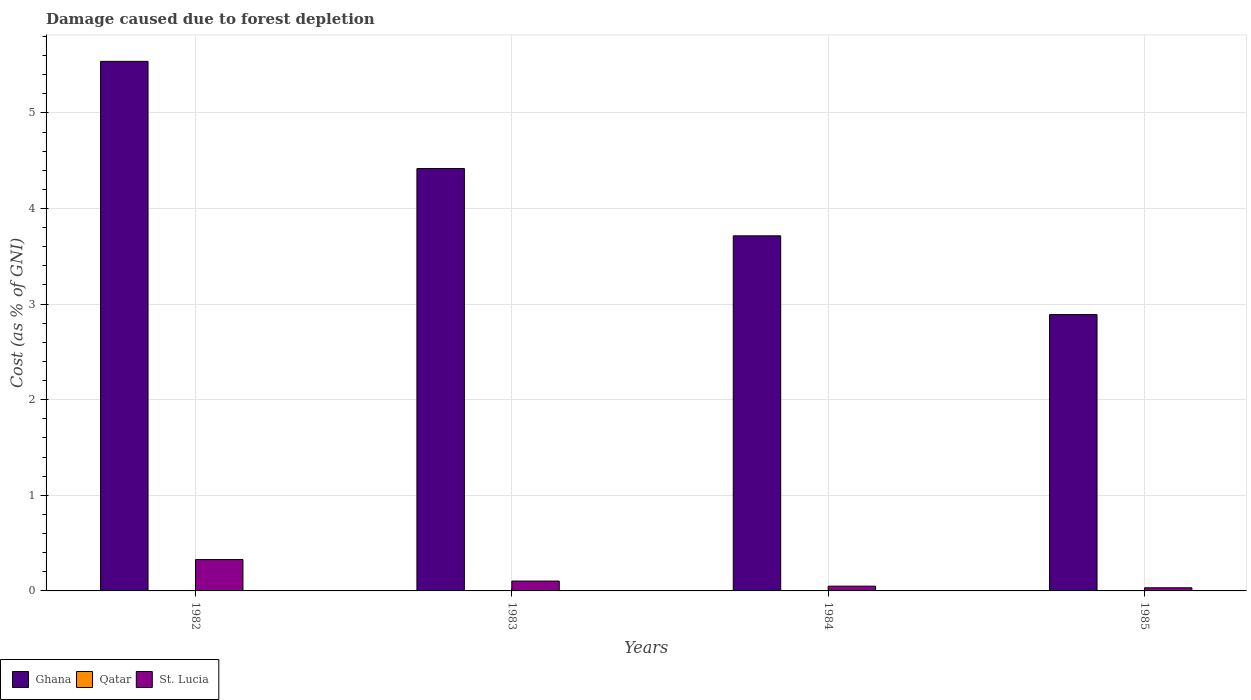How many different coloured bars are there?
Ensure brevity in your answer.  3. Are the number of bars on each tick of the X-axis equal?
Your answer should be compact. Yes. How many bars are there on the 4th tick from the left?
Give a very brief answer. 3. How many bars are there on the 3rd tick from the right?
Give a very brief answer. 3. What is the label of the 1st group of bars from the left?
Your answer should be very brief. 1982. In how many cases, is the number of bars for a given year not equal to the number of legend labels?
Make the answer very short. 0. What is the cost of damage caused due to forest depletion in Qatar in 1985?
Ensure brevity in your answer.  0. Across all years, what is the maximum cost of damage caused due to forest depletion in St. Lucia?
Make the answer very short. 0.33. Across all years, what is the minimum cost of damage caused due to forest depletion in Qatar?
Provide a succinct answer. 0. What is the total cost of damage caused due to forest depletion in St. Lucia in the graph?
Provide a succinct answer. 0.51. What is the difference between the cost of damage caused due to forest depletion in St. Lucia in 1983 and that in 1985?
Your answer should be compact. 0.07. What is the difference between the cost of damage caused due to forest depletion in Qatar in 1983 and the cost of damage caused due to forest depletion in St. Lucia in 1985?
Provide a short and direct response. -0.03. What is the average cost of damage caused due to forest depletion in Qatar per year?
Make the answer very short. 0. In the year 1984, what is the difference between the cost of damage caused due to forest depletion in Ghana and cost of damage caused due to forest depletion in St. Lucia?
Keep it short and to the point. 3.66. In how many years, is the cost of damage caused due to forest depletion in Qatar greater than 5.4 %?
Provide a succinct answer. 0. What is the ratio of the cost of damage caused due to forest depletion in Qatar in 1982 to that in 1983?
Your answer should be compact. 0.86. Is the cost of damage caused due to forest depletion in Ghana in 1982 less than that in 1984?
Your answer should be compact. No. Is the difference between the cost of damage caused due to forest depletion in Ghana in 1983 and 1984 greater than the difference between the cost of damage caused due to forest depletion in St. Lucia in 1983 and 1984?
Your answer should be compact. Yes. What is the difference between the highest and the second highest cost of damage caused due to forest depletion in Ghana?
Provide a succinct answer. 1.12. What is the difference between the highest and the lowest cost of damage caused due to forest depletion in Qatar?
Your answer should be compact. 0. Is the sum of the cost of damage caused due to forest depletion in St. Lucia in 1984 and 1985 greater than the maximum cost of damage caused due to forest depletion in Qatar across all years?
Offer a very short reply. Yes. How many bars are there?
Keep it short and to the point. 12. Are all the bars in the graph horizontal?
Offer a terse response. No. What is the difference between two consecutive major ticks on the Y-axis?
Provide a short and direct response. 1. Are the values on the major ticks of Y-axis written in scientific E-notation?
Provide a succinct answer. No. Does the graph contain any zero values?
Offer a terse response. No. How are the legend labels stacked?
Your response must be concise. Horizontal. What is the title of the graph?
Provide a succinct answer. Damage caused due to forest depletion. Does "San Marino" appear as one of the legend labels in the graph?
Your response must be concise. No. What is the label or title of the X-axis?
Your answer should be very brief. Years. What is the label or title of the Y-axis?
Provide a short and direct response. Cost (as % of GNI). What is the Cost (as % of GNI) in Ghana in 1982?
Make the answer very short. 5.54. What is the Cost (as % of GNI) of Qatar in 1982?
Your response must be concise. 0. What is the Cost (as % of GNI) in St. Lucia in 1982?
Keep it short and to the point. 0.33. What is the Cost (as % of GNI) of Ghana in 1983?
Keep it short and to the point. 4.42. What is the Cost (as % of GNI) in Qatar in 1983?
Your answer should be compact. 0. What is the Cost (as % of GNI) of St. Lucia in 1983?
Your answer should be compact. 0.1. What is the Cost (as % of GNI) of Ghana in 1984?
Keep it short and to the point. 3.71. What is the Cost (as % of GNI) of Qatar in 1984?
Your answer should be very brief. 0. What is the Cost (as % of GNI) of St. Lucia in 1984?
Your answer should be very brief. 0.05. What is the Cost (as % of GNI) of Ghana in 1985?
Provide a short and direct response. 2.89. What is the Cost (as % of GNI) of Qatar in 1985?
Give a very brief answer. 0. What is the Cost (as % of GNI) in St. Lucia in 1985?
Ensure brevity in your answer.  0.03. Across all years, what is the maximum Cost (as % of GNI) in Ghana?
Provide a short and direct response. 5.54. Across all years, what is the maximum Cost (as % of GNI) of Qatar?
Provide a succinct answer. 0. Across all years, what is the maximum Cost (as % of GNI) of St. Lucia?
Offer a terse response. 0.33. Across all years, what is the minimum Cost (as % of GNI) of Ghana?
Give a very brief answer. 2.89. Across all years, what is the minimum Cost (as % of GNI) in Qatar?
Provide a succinct answer. 0. Across all years, what is the minimum Cost (as % of GNI) in St. Lucia?
Keep it short and to the point. 0.03. What is the total Cost (as % of GNI) in Ghana in the graph?
Provide a short and direct response. 16.56. What is the total Cost (as % of GNI) in Qatar in the graph?
Your answer should be very brief. 0. What is the total Cost (as % of GNI) of St. Lucia in the graph?
Provide a succinct answer. 0.51. What is the difference between the Cost (as % of GNI) in Ghana in 1982 and that in 1983?
Your response must be concise. 1.12. What is the difference between the Cost (as % of GNI) in Qatar in 1982 and that in 1983?
Your response must be concise. -0. What is the difference between the Cost (as % of GNI) in St. Lucia in 1982 and that in 1983?
Offer a very short reply. 0.22. What is the difference between the Cost (as % of GNI) of Ghana in 1982 and that in 1984?
Your answer should be compact. 1.83. What is the difference between the Cost (as % of GNI) in Qatar in 1982 and that in 1984?
Give a very brief answer. -0. What is the difference between the Cost (as % of GNI) of St. Lucia in 1982 and that in 1984?
Offer a very short reply. 0.28. What is the difference between the Cost (as % of GNI) of Ghana in 1982 and that in 1985?
Give a very brief answer. 2.65. What is the difference between the Cost (as % of GNI) in St. Lucia in 1982 and that in 1985?
Offer a very short reply. 0.29. What is the difference between the Cost (as % of GNI) of Ghana in 1983 and that in 1984?
Make the answer very short. 0.7. What is the difference between the Cost (as % of GNI) of Qatar in 1983 and that in 1984?
Your answer should be compact. -0. What is the difference between the Cost (as % of GNI) of St. Lucia in 1983 and that in 1984?
Offer a very short reply. 0.05. What is the difference between the Cost (as % of GNI) in Ghana in 1983 and that in 1985?
Offer a terse response. 1.53. What is the difference between the Cost (as % of GNI) of St. Lucia in 1983 and that in 1985?
Keep it short and to the point. 0.07. What is the difference between the Cost (as % of GNI) of Ghana in 1984 and that in 1985?
Provide a short and direct response. 0.82. What is the difference between the Cost (as % of GNI) of Qatar in 1984 and that in 1985?
Offer a very short reply. 0. What is the difference between the Cost (as % of GNI) in St. Lucia in 1984 and that in 1985?
Provide a succinct answer. 0.02. What is the difference between the Cost (as % of GNI) in Ghana in 1982 and the Cost (as % of GNI) in Qatar in 1983?
Give a very brief answer. 5.54. What is the difference between the Cost (as % of GNI) of Ghana in 1982 and the Cost (as % of GNI) of St. Lucia in 1983?
Provide a short and direct response. 5.44. What is the difference between the Cost (as % of GNI) of Qatar in 1982 and the Cost (as % of GNI) of St. Lucia in 1983?
Offer a terse response. -0.1. What is the difference between the Cost (as % of GNI) of Ghana in 1982 and the Cost (as % of GNI) of Qatar in 1984?
Provide a succinct answer. 5.54. What is the difference between the Cost (as % of GNI) of Ghana in 1982 and the Cost (as % of GNI) of St. Lucia in 1984?
Make the answer very short. 5.49. What is the difference between the Cost (as % of GNI) in Qatar in 1982 and the Cost (as % of GNI) in St. Lucia in 1984?
Give a very brief answer. -0.05. What is the difference between the Cost (as % of GNI) in Ghana in 1982 and the Cost (as % of GNI) in Qatar in 1985?
Your response must be concise. 5.54. What is the difference between the Cost (as % of GNI) of Ghana in 1982 and the Cost (as % of GNI) of St. Lucia in 1985?
Offer a very short reply. 5.51. What is the difference between the Cost (as % of GNI) in Qatar in 1982 and the Cost (as % of GNI) in St. Lucia in 1985?
Make the answer very short. -0.03. What is the difference between the Cost (as % of GNI) of Ghana in 1983 and the Cost (as % of GNI) of Qatar in 1984?
Provide a short and direct response. 4.42. What is the difference between the Cost (as % of GNI) in Ghana in 1983 and the Cost (as % of GNI) in St. Lucia in 1984?
Make the answer very short. 4.37. What is the difference between the Cost (as % of GNI) of Qatar in 1983 and the Cost (as % of GNI) of St. Lucia in 1984?
Ensure brevity in your answer.  -0.05. What is the difference between the Cost (as % of GNI) in Ghana in 1983 and the Cost (as % of GNI) in Qatar in 1985?
Provide a short and direct response. 4.42. What is the difference between the Cost (as % of GNI) in Ghana in 1983 and the Cost (as % of GNI) in St. Lucia in 1985?
Ensure brevity in your answer.  4.39. What is the difference between the Cost (as % of GNI) in Qatar in 1983 and the Cost (as % of GNI) in St. Lucia in 1985?
Offer a very short reply. -0.03. What is the difference between the Cost (as % of GNI) in Ghana in 1984 and the Cost (as % of GNI) in Qatar in 1985?
Keep it short and to the point. 3.71. What is the difference between the Cost (as % of GNI) in Ghana in 1984 and the Cost (as % of GNI) in St. Lucia in 1985?
Give a very brief answer. 3.68. What is the difference between the Cost (as % of GNI) of Qatar in 1984 and the Cost (as % of GNI) of St. Lucia in 1985?
Make the answer very short. -0.03. What is the average Cost (as % of GNI) in Ghana per year?
Offer a very short reply. 4.14. What is the average Cost (as % of GNI) in Qatar per year?
Ensure brevity in your answer.  0. What is the average Cost (as % of GNI) of St. Lucia per year?
Your answer should be compact. 0.13. In the year 1982, what is the difference between the Cost (as % of GNI) in Ghana and Cost (as % of GNI) in Qatar?
Ensure brevity in your answer.  5.54. In the year 1982, what is the difference between the Cost (as % of GNI) in Ghana and Cost (as % of GNI) in St. Lucia?
Offer a very short reply. 5.21. In the year 1982, what is the difference between the Cost (as % of GNI) in Qatar and Cost (as % of GNI) in St. Lucia?
Offer a terse response. -0.33. In the year 1983, what is the difference between the Cost (as % of GNI) of Ghana and Cost (as % of GNI) of Qatar?
Give a very brief answer. 4.42. In the year 1983, what is the difference between the Cost (as % of GNI) in Ghana and Cost (as % of GNI) in St. Lucia?
Your answer should be compact. 4.32. In the year 1983, what is the difference between the Cost (as % of GNI) in Qatar and Cost (as % of GNI) in St. Lucia?
Provide a short and direct response. -0.1. In the year 1984, what is the difference between the Cost (as % of GNI) in Ghana and Cost (as % of GNI) in Qatar?
Offer a very short reply. 3.71. In the year 1984, what is the difference between the Cost (as % of GNI) of Ghana and Cost (as % of GNI) of St. Lucia?
Make the answer very short. 3.66. In the year 1984, what is the difference between the Cost (as % of GNI) of Qatar and Cost (as % of GNI) of St. Lucia?
Your answer should be compact. -0.05. In the year 1985, what is the difference between the Cost (as % of GNI) of Ghana and Cost (as % of GNI) of Qatar?
Offer a very short reply. 2.89. In the year 1985, what is the difference between the Cost (as % of GNI) in Ghana and Cost (as % of GNI) in St. Lucia?
Ensure brevity in your answer.  2.86. In the year 1985, what is the difference between the Cost (as % of GNI) of Qatar and Cost (as % of GNI) of St. Lucia?
Make the answer very short. -0.03. What is the ratio of the Cost (as % of GNI) of Ghana in 1982 to that in 1983?
Make the answer very short. 1.25. What is the ratio of the Cost (as % of GNI) in Qatar in 1982 to that in 1983?
Provide a succinct answer. 0.86. What is the ratio of the Cost (as % of GNI) of St. Lucia in 1982 to that in 1983?
Give a very brief answer. 3.18. What is the ratio of the Cost (as % of GNI) of Ghana in 1982 to that in 1984?
Provide a short and direct response. 1.49. What is the ratio of the Cost (as % of GNI) in Qatar in 1982 to that in 1984?
Your response must be concise. 0.71. What is the ratio of the Cost (as % of GNI) in St. Lucia in 1982 to that in 1984?
Make the answer very short. 6.58. What is the ratio of the Cost (as % of GNI) in Ghana in 1982 to that in 1985?
Your answer should be compact. 1.92. What is the ratio of the Cost (as % of GNI) of Qatar in 1982 to that in 1985?
Provide a short and direct response. 1.54. What is the ratio of the Cost (as % of GNI) in St. Lucia in 1982 to that in 1985?
Provide a succinct answer. 9.94. What is the ratio of the Cost (as % of GNI) in Ghana in 1983 to that in 1984?
Ensure brevity in your answer.  1.19. What is the ratio of the Cost (as % of GNI) of Qatar in 1983 to that in 1984?
Your answer should be compact. 0.82. What is the ratio of the Cost (as % of GNI) of St. Lucia in 1983 to that in 1984?
Provide a short and direct response. 2.07. What is the ratio of the Cost (as % of GNI) of Ghana in 1983 to that in 1985?
Ensure brevity in your answer.  1.53. What is the ratio of the Cost (as % of GNI) in Qatar in 1983 to that in 1985?
Keep it short and to the point. 1.78. What is the ratio of the Cost (as % of GNI) in St. Lucia in 1983 to that in 1985?
Keep it short and to the point. 3.13. What is the ratio of the Cost (as % of GNI) of Ghana in 1984 to that in 1985?
Make the answer very short. 1.29. What is the ratio of the Cost (as % of GNI) in Qatar in 1984 to that in 1985?
Your answer should be very brief. 2.17. What is the ratio of the Cost (as % of GNI) of St. Lucia in 1984 to that in 1985?
Keep it short and to the point. 1.51. What is the difference between the highest and the second highest Cost (as % of GNI) of Ghana?
Your response must be concise. 1.12. What is the difference between the highest and the second highest Cost (as % of GNI) in St. Lucia?
Provide a short and direct response. 0.22. What is the difference between the highest and the lowest Cost (as % of GNI) in Ghana?
Your response must be concise. 2.65. What is the difference between the highest and the lowest Cost (as % of GNI) of St. Lucia?
Ensure brevity in your answer.  0.29. 